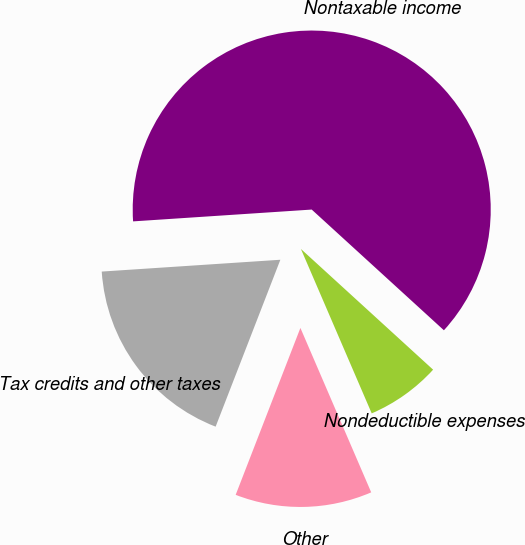Convert chart to OTSL. <chart><loc_0><loc_0><loc_500><loc_500><pie_chart><fcel>Nondeductible expenses<fcel>Nontaxable income<fcel>Tax credits and other taxes<fcel>Other<nl><fcel>6.75%<fcel>62.83%<fcel>18.06%<fcel>12.36%<nl></chart> 